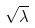<formula> <loc_0><loc_0><loc_500><loc_500>\sqrt { \lambda }</formula> 